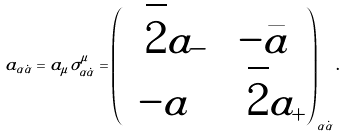Convert formula to latex. <formula><loc_0><loc_0><loc_500><loc_500>a _ { \alpha \dot { \alpha } } = a _ { \mu } \sigma ^ { \mu } _ { \alpha \dot { \alpha } } = \begin{pmatrix} \sqrt { 2 } a _ { - } & - \bar { a } \\ - a & \sqrt { 2 } a _ { + } \end{pmatrix} _ { \alpha \dot { \alpha } } .</formula> 